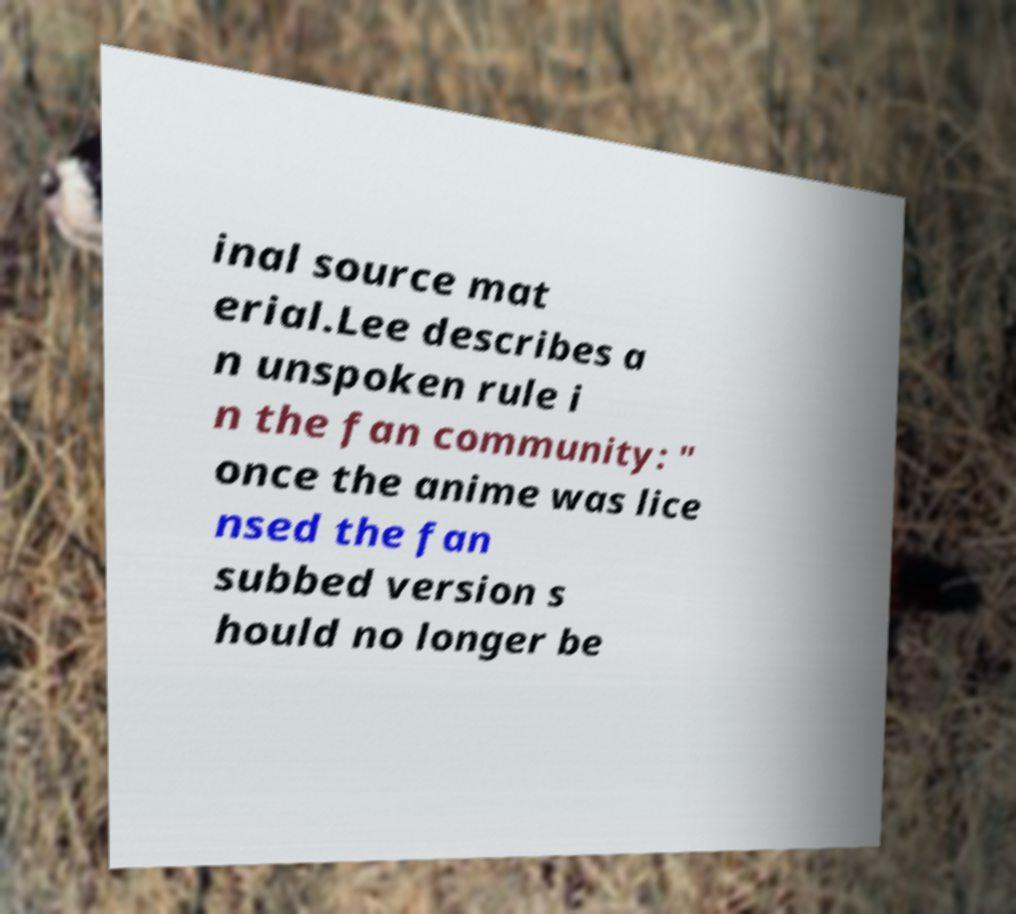For documentation purposes, I need the text within this image transcribed. Could you provide that? inal source mat erial.Lee describes a n unspoken rule i n the fan community: " once the anime was lice nsed the fan subbed version s hould no longer be 